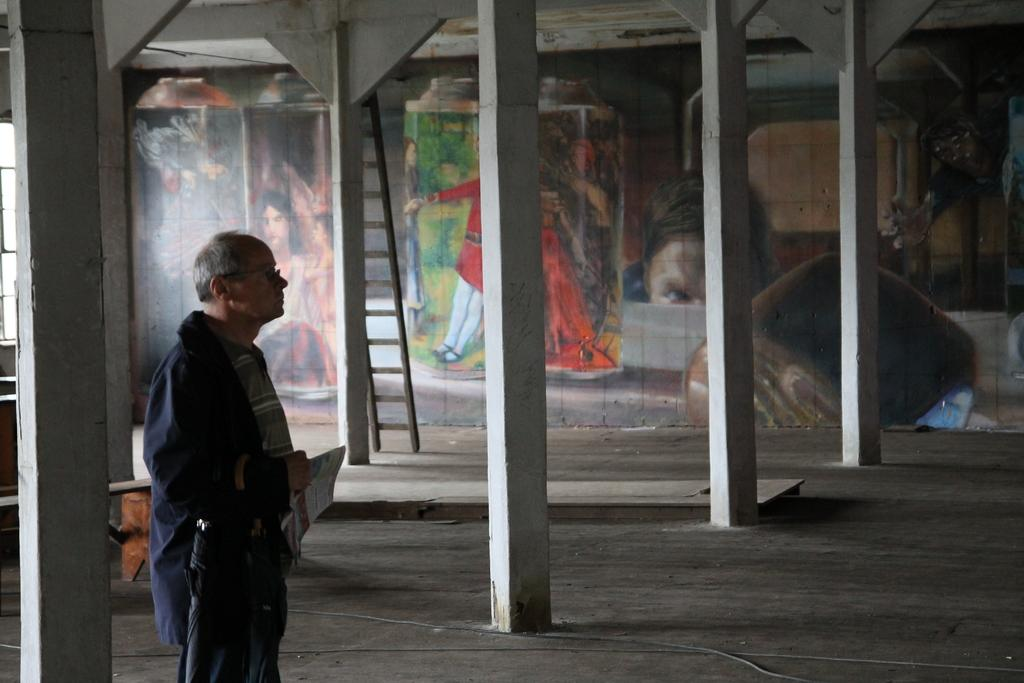What is the main subject of the image? There is a man standing in the image. What architectural features are present in the image? There are pillars in the image. What is the man using to reach a higher area? There is a ladder in the image that the man might be using. What type of artwork can be seen in the background? There are paintings in the background of the image. What type of dirt can be seen on the man's shoes in the image? There is no dirt visible on the man's shoes in the image. What kind of net is being used to catch fish in the image? There is no net or fishing activity present in the image. 